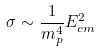Convert formula to latex. <formula><loc_0><loc_0><loc_500><loc_500>\sigma \sim \frac { 1 } { m ^ { 4 } _ { p } } E ^ { 2 } _ { c m }</formula> 